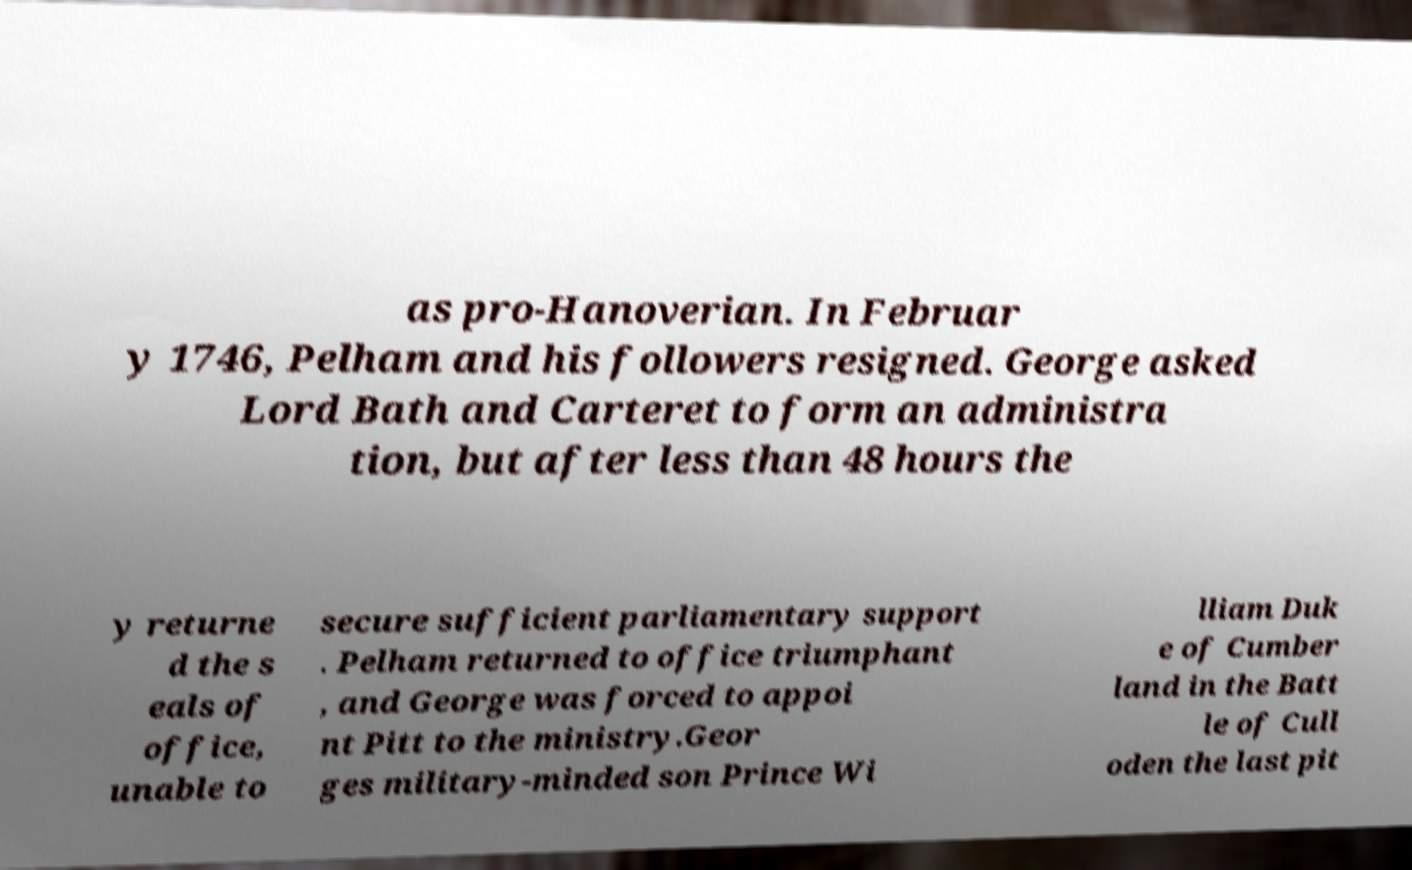What messages or text are displayed in this image? I need them in a readable, typed format. as pro-Hanoverian. In Februar y 1746, Pelham and his followers resigned. George asked Lord Bath and Carteret to form an administra tion, but after less than 48 hours the y returne d the s eals of office, unable to secure sufficient parliamentary support . Pelham returned to office triumphant , and George was forced to appoi nt Pitt to the ministry.Geor ges military-minded son Prince Wi lliam Duk e of Cumber land in the Batt le of Cull oden the last pit 